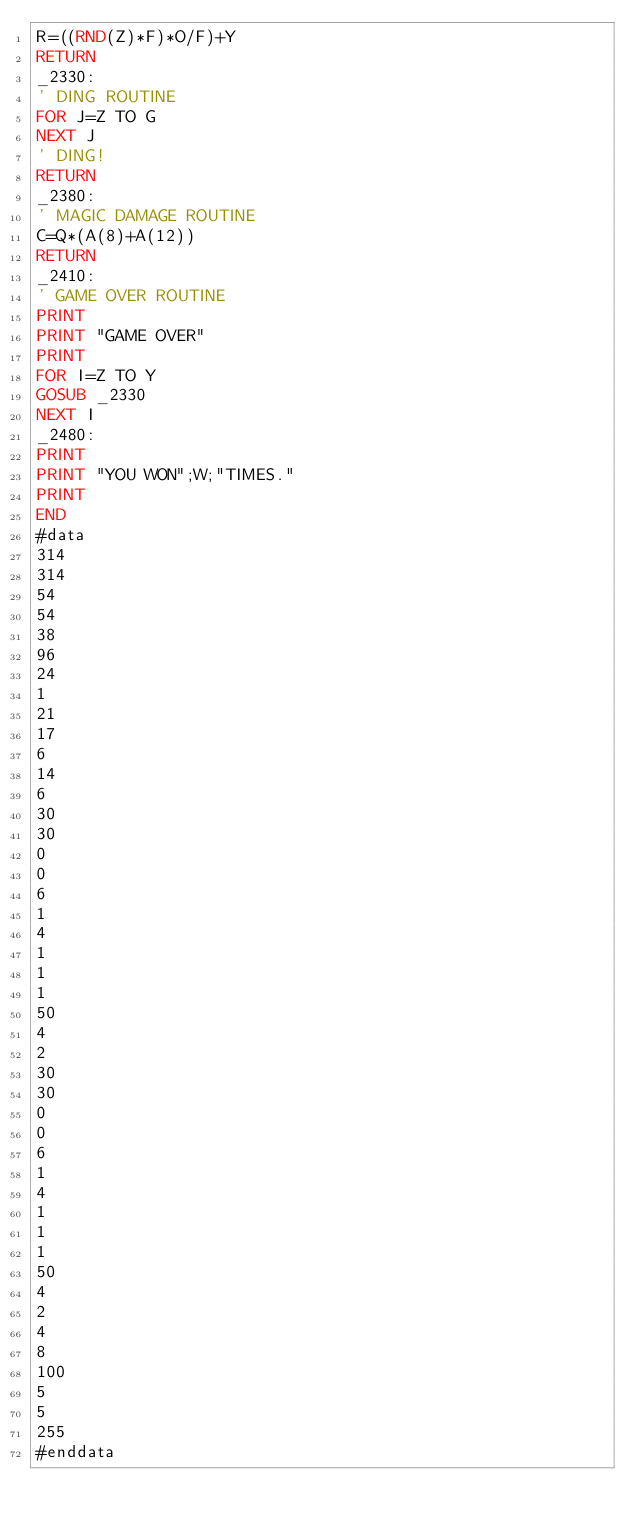<code> <loc_0><loc_0><loc_500><loc_500><_VisualBasic_>R=((RND(Z)*F)*O/F)+Y
RETURN
_2330:
' DING ROUTINE
FOR J=Z TO G
NEXT J
' DING!
RETURN
_2380:
' MAGIC DAMAGE ROUTINE
C=Q*(A(8)+A(12))
RETURN
_2410:
' GAME OVER ROUTINE
PRINT
PRINT "GAME OVER"
PRINT
FOR I=Z TO Y
GOSUB _2330
NEXT I
_2480:
PRINT
PRINT "YOU WON";W;"TIMES."
PRINT
END
#data
314
314
54
54
38
96
24
1
21
17
6
14
6
30
30
0
0
6
1
4
1
1
1
50
4
2
30
30
0
0
6
1
4
1
1
1
50
4
2
4
8
100
5
5
255
#enddata
</code> 